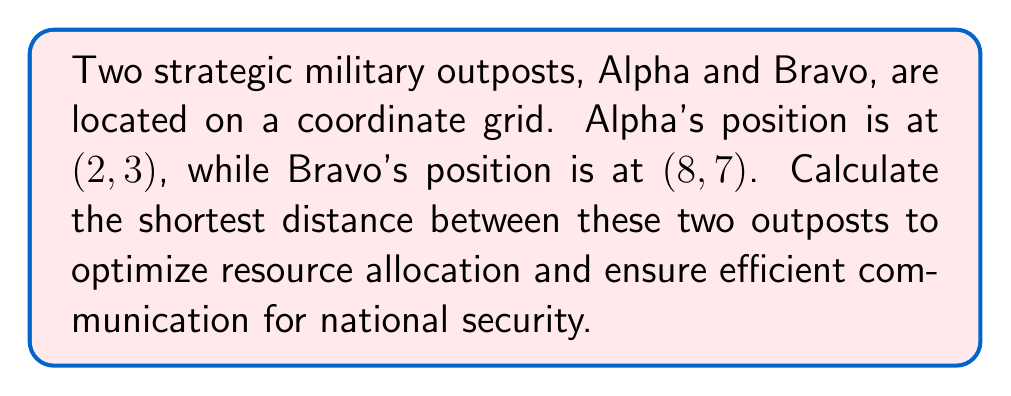Solve this math problem. To find the shortest distance between two points on a coordinate plane, we use the distance formula derived from the Pythagorean theorem:

$$d = \sqrt{(x_2 - x_1)^2 + (y_2 - y_1)^2}$$

Where $(x_1, y_1)$ are the coordinates of the first point and $(x_2, y_2)$ are the coordinates of the second point.

Let's plug in our values:
$(x_1, y_1) = (2, 3)$ for Alpha
$(x_2, y_2) = (8, 7)$ for Bravo

Now, let's calculate:

1) $x_2 - x_1 = 8 - 2 = 6$
2) $y_2 - y_1 = 7 - 3 = 4$

Plugging these into our formula:

$$d = \sqrt{(6)^2 + (4)^2}$$

$$d = \sqrt{36 + 16}$$

$$d = \sqrt{52}$$

$$d = 2\sqrt{13}$$

This can be left in simplified radical form or approximated to a decimal.

[asy]
unitsize(1cm);
dot((2,3));
dot((8,7));
draw((2,3)--(8,7), arrow=Arrow(TeXHead));
label("Alpha (2,3)", (2,3), SW);
label("Bravo (8,7)", (8,7), NE);
label("$2\sqrt{13}$", (5,5), NW);
[/asy]
Answer: $2\sqrt{13}$ units 